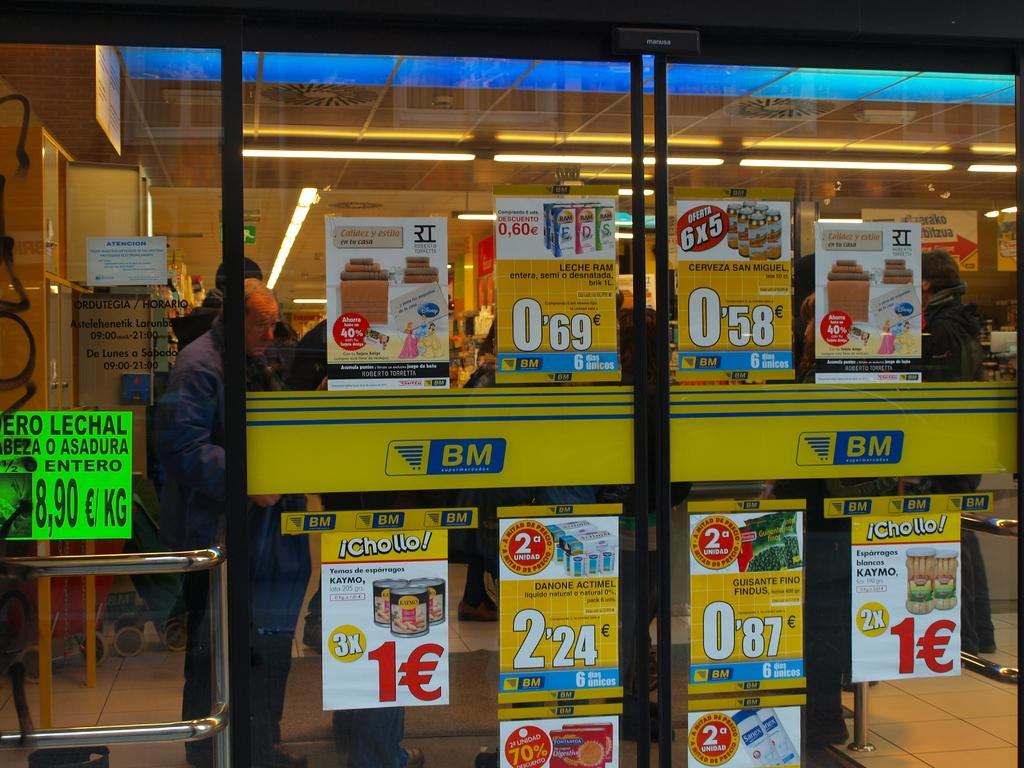<image>
Provide a brief description of the given image. items for sale one of which is 0,69 